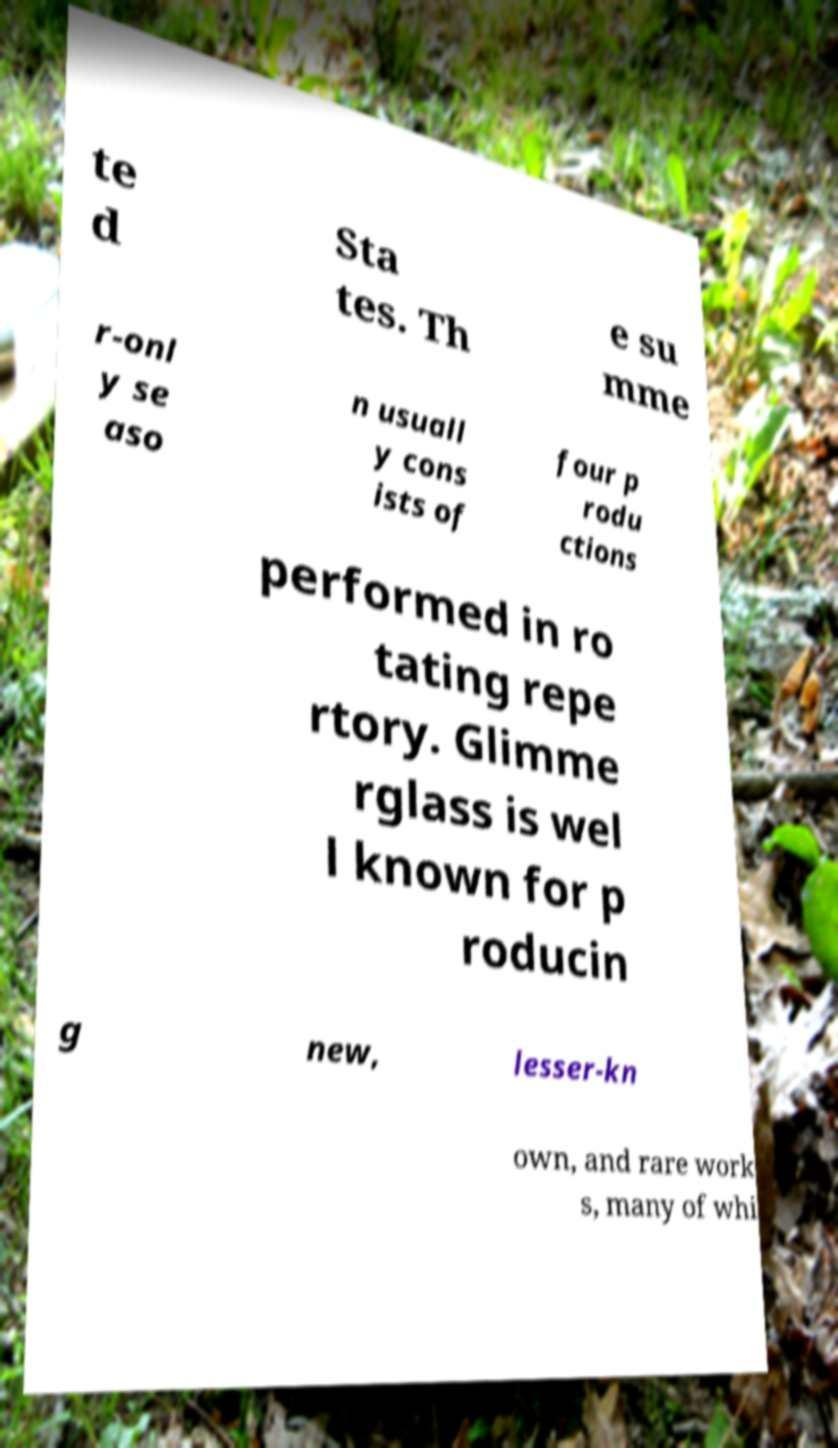I need the written content from this picture converted into text. Can you do that? te d Sta tes. Th e su mme r-onl y se aso n usuall y cons ists of four p rodu ctions performed in ro tating repe rtory. Glimme rglass is wel l known for p roducin g new, lesser-kn own, and rare work s, many of whi 